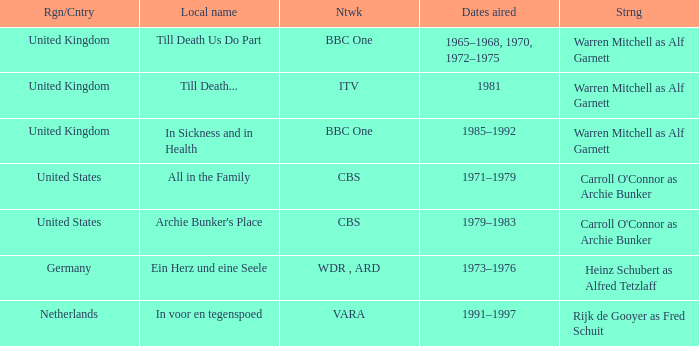What dates did the episodes air in the United States? 1971–1979, 1979–1983. 